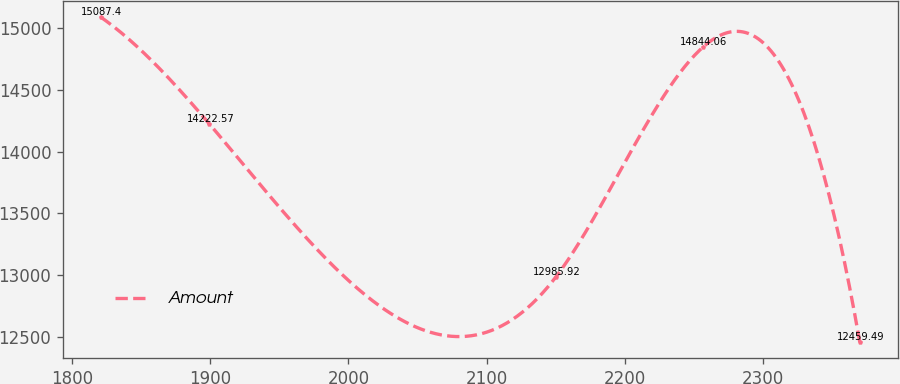Convert chart. <chart><loc_0><loc_0><loc_500><loc_500><line_chart><ecel><fcel>Amount<nl><fcel>1820.94<fcel>15087.4<nl><fcel>1899.49<fcel>14222.6<nl><fcel>2149.99<fcel>12985.9<nl><fcel>2256.21<fcel>14844.1<nl><fcel>2369.69<fcel>12459.5<nl></chart> 